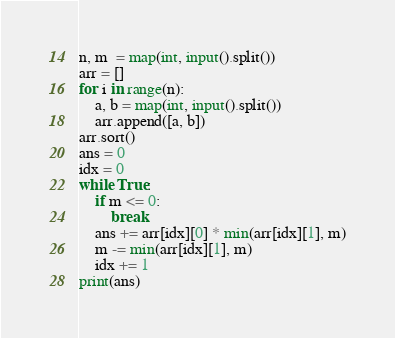<code> <loc_0><loc_0><loc_500><loc_500><_Python_>n, m  = map(int, input().split())
arr = []
for i in range(n):
    a, b = map(int, input().split())
    arr.append([a, b])
arr.sort()
ans = 0
idx = 0
while True:
    if m <= 0:
        break
    ans += arr[idx][0] * min(arr[idx][1], m)
    m -= min(arr[idx][1], m)
    idx += 1
print(ans)
</code> 